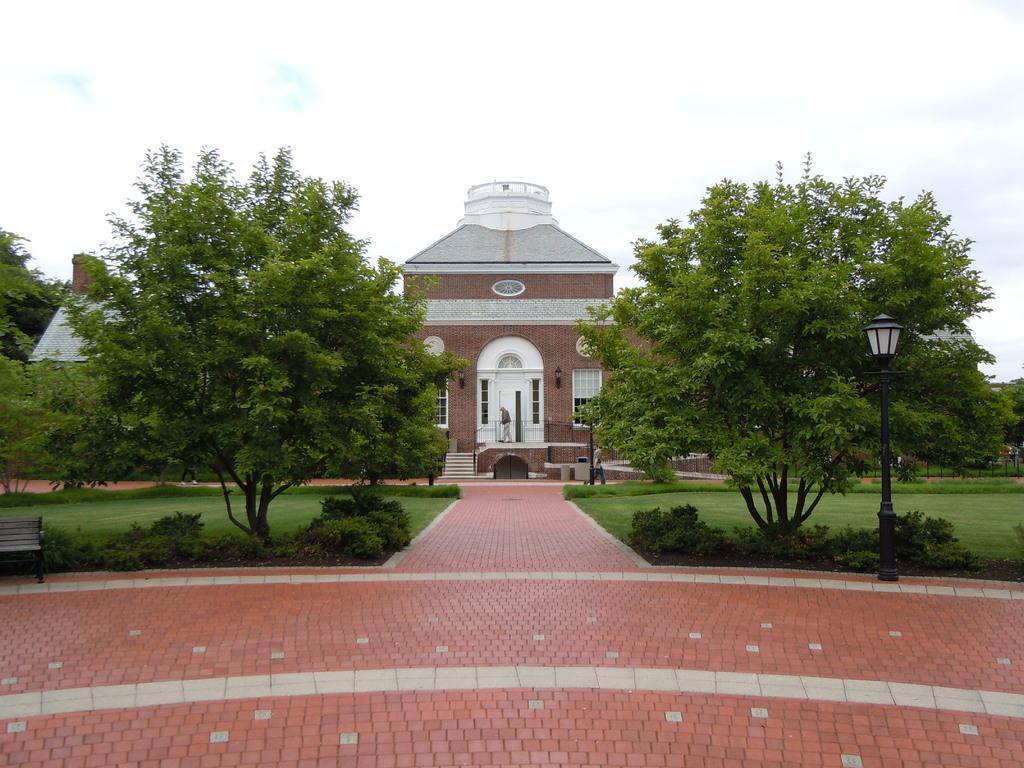How would you summarize this image in a sentence or two? In this image I can see the light pole, trees in green color. Background I can see the building in brown and white color and the sky is in white color. 